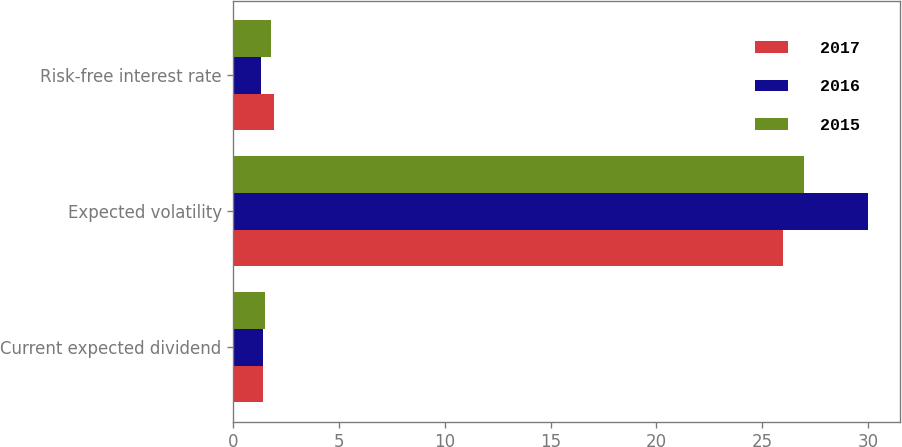Convert chart. <chart><loc_0><loc_0><loc_500><loc_500><stacked_bar_chart><ecel><fcel>Current expected dividend<fcel>Expected volatility<fcel>Risk-free interest rate<nl><fcel>2017<fcel>1.4<fcel>26<fcel>1.9<nl><fcel>2016<fcel>1.4<fcel>30<fcel>1.3<nl><fcel>2015<fcel>1.5<fcel>27<fcel>1.8<nl></chart> 